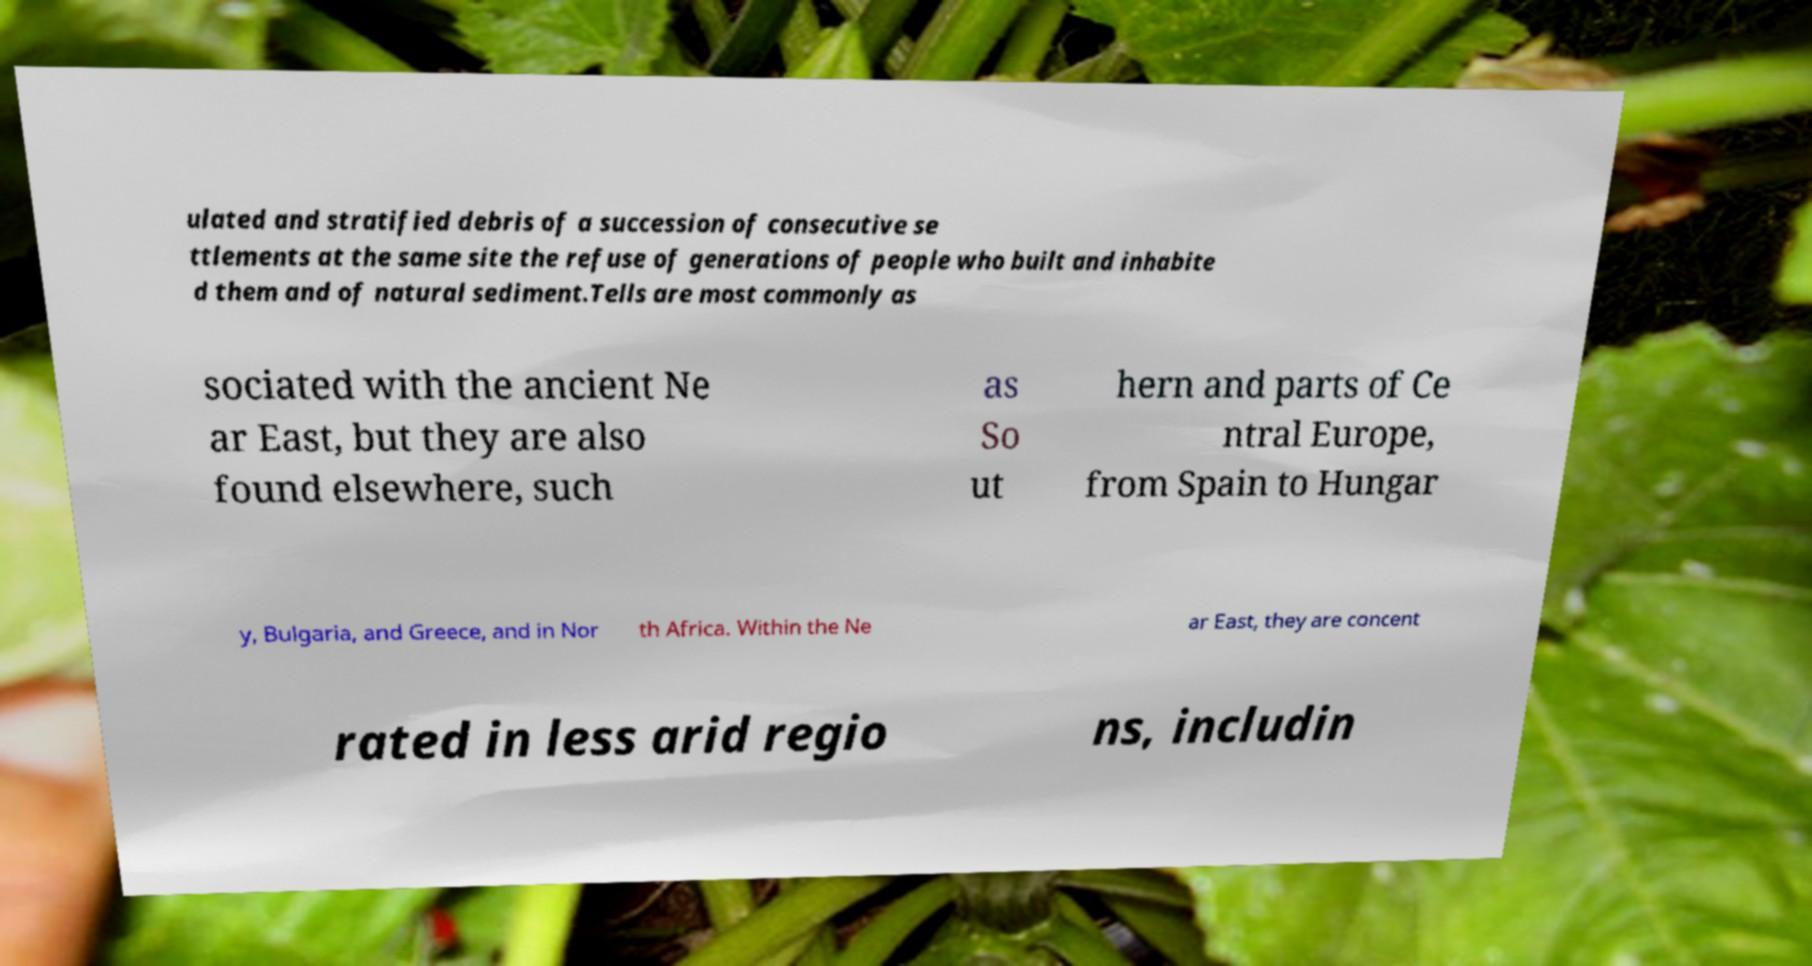For documentation purposes, I need the text within this image transcribed. Could you provide that? ulated and stratified debris of a succession of consecutive se ttlements at the same site the refuse of generations of people who built and inhabite d them and of natural sediment.Tells are most commonly as sociated with the ancient Ne ar East, but they are also found elsewhere, such as So ut hern and parts of Ce ntral Europe, from Spain to Hungar y, Bulgaria, and Greece, and in Nor th Africa. Within the Ne ar East, they are concent rated in less arid regio ns, includin 